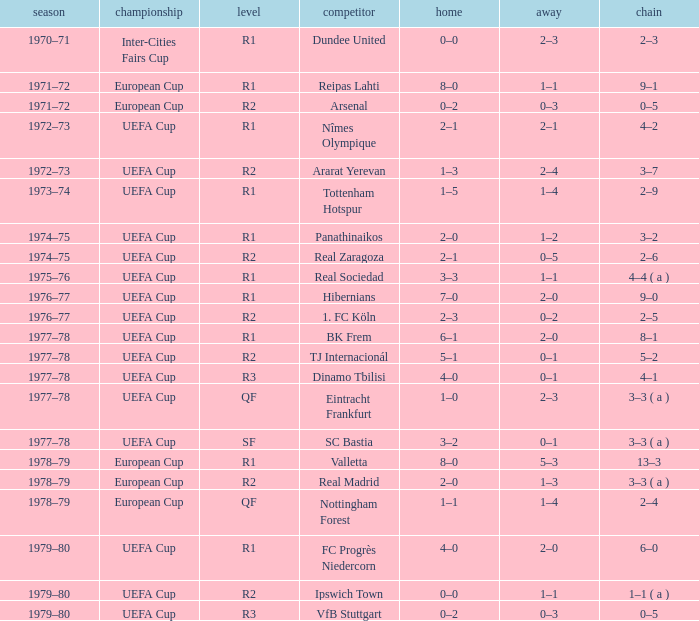Which Home has a Round of r1, and an Opponent of dundee united? 0–0. Would you mind parsing the complete table? {'header': ['season', 'championship', 'level', 'competitor', 'home', 'away', 'chain'], 'rows': [['1970–71', 'Inter-Cities Fairs Cup', 'R1', 'Dundee United', '0–0', '2–3', '2–3'], ['1971–72', 'European Cup', 'R1', 'Reipas Lahti', '8–0', '1–1', '9–1'], ['1971–72', 'European Cup', 'R2', 'Arsenal', '0–2', '0–3', '0–5'], ['1972–73', 'UEFA Cup', 'R1', 'Nîmes Olympique', '2–1', '2–1', '4–2'], ['1972–73', 'UEFA Cup', 'R2', 'Ararat Yerevan', '1–3', '2–4', '3–7'], ['1973–74', 'UEFA Cup', 'R1', 'Tottenham Hotspur', '1–5', '1–4', '2–9'], ['1974–75', 'UEFA Cup', 'R1', 'Panathinaikos', '2–0', '1–2', '3–2'], ['1974–75', 'UEFA Cup', 'R2', 'Real Zaragoza', '2–1', '0–5', '2–6'], ['1975–76', 'UEFA Cup', 'R1', 'Real Sociedad', '3–3', '1–1', '4–4 ( a )'], ['1976–77', 'UEFA Cup', 'R1', 'Hibernians', '7–0', '2–0', '9–0'], ['1976–77', 'UEFA Cup', 'R2', '1. FC Köln', '2–3', '0–2', '2–5'], ['1977–78', 'UEFA Cup', 'R1', 'BK Frem', '6–1', '2–0', '8–1'], ['1977–78', 'UEFA Cup', 'R2', 'TJ Internacionál', '5–1', '0–1', '5–2'], ['1977–78', 'UEFA Cup', 'R3', 'Dinamo Tbilisi', '4–0', '0–1', '4–1'], ['1977–78', 'UEFA Cup', 'QF', 'Eintracht Frankfurt', '1–0', '2–3', '3–3 ( a )'], ['1977–78', 'UEFA Cup', 'SF', 'SC Bastia', '3–2', '0–1', '3–3 ( a )'], ['1978–79', 'European Cup', 'R1', 'Valletta', '8–0', '5–3', '13–3'], ['1978–79', 'European Cup', 'R2', 'Real Madrid', '2–0', '1–3', '3–3 ( a )'], ['1978–79', 'European Cup', 'QF', 'Nottingham Forest', '1–1', '1–4', '2–4'], ['1979–80', 'UEFA Cup', 'R1', 'FC Progrès Niedercorn', '4–0', '2–0', '6–0'], ['1979–80', 'UEFA Cup', 'R2', 'Ipswich Town', '0–0', '1–1', '1–1 ( a )'], ['1979–80', 'UEFA Cup', 'R3', 'VfB Stuttgart', '0–2', '0–3', '0–5']]} 